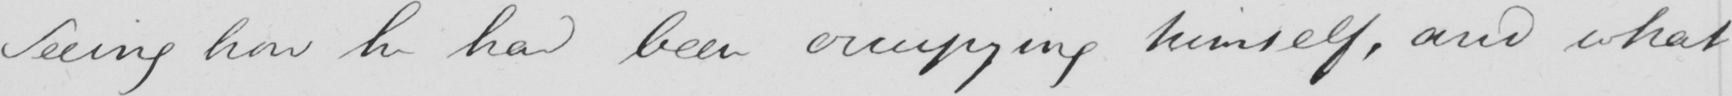Can you tell me what this handwritten text says? Seeing how he had been occupying himself , and what 